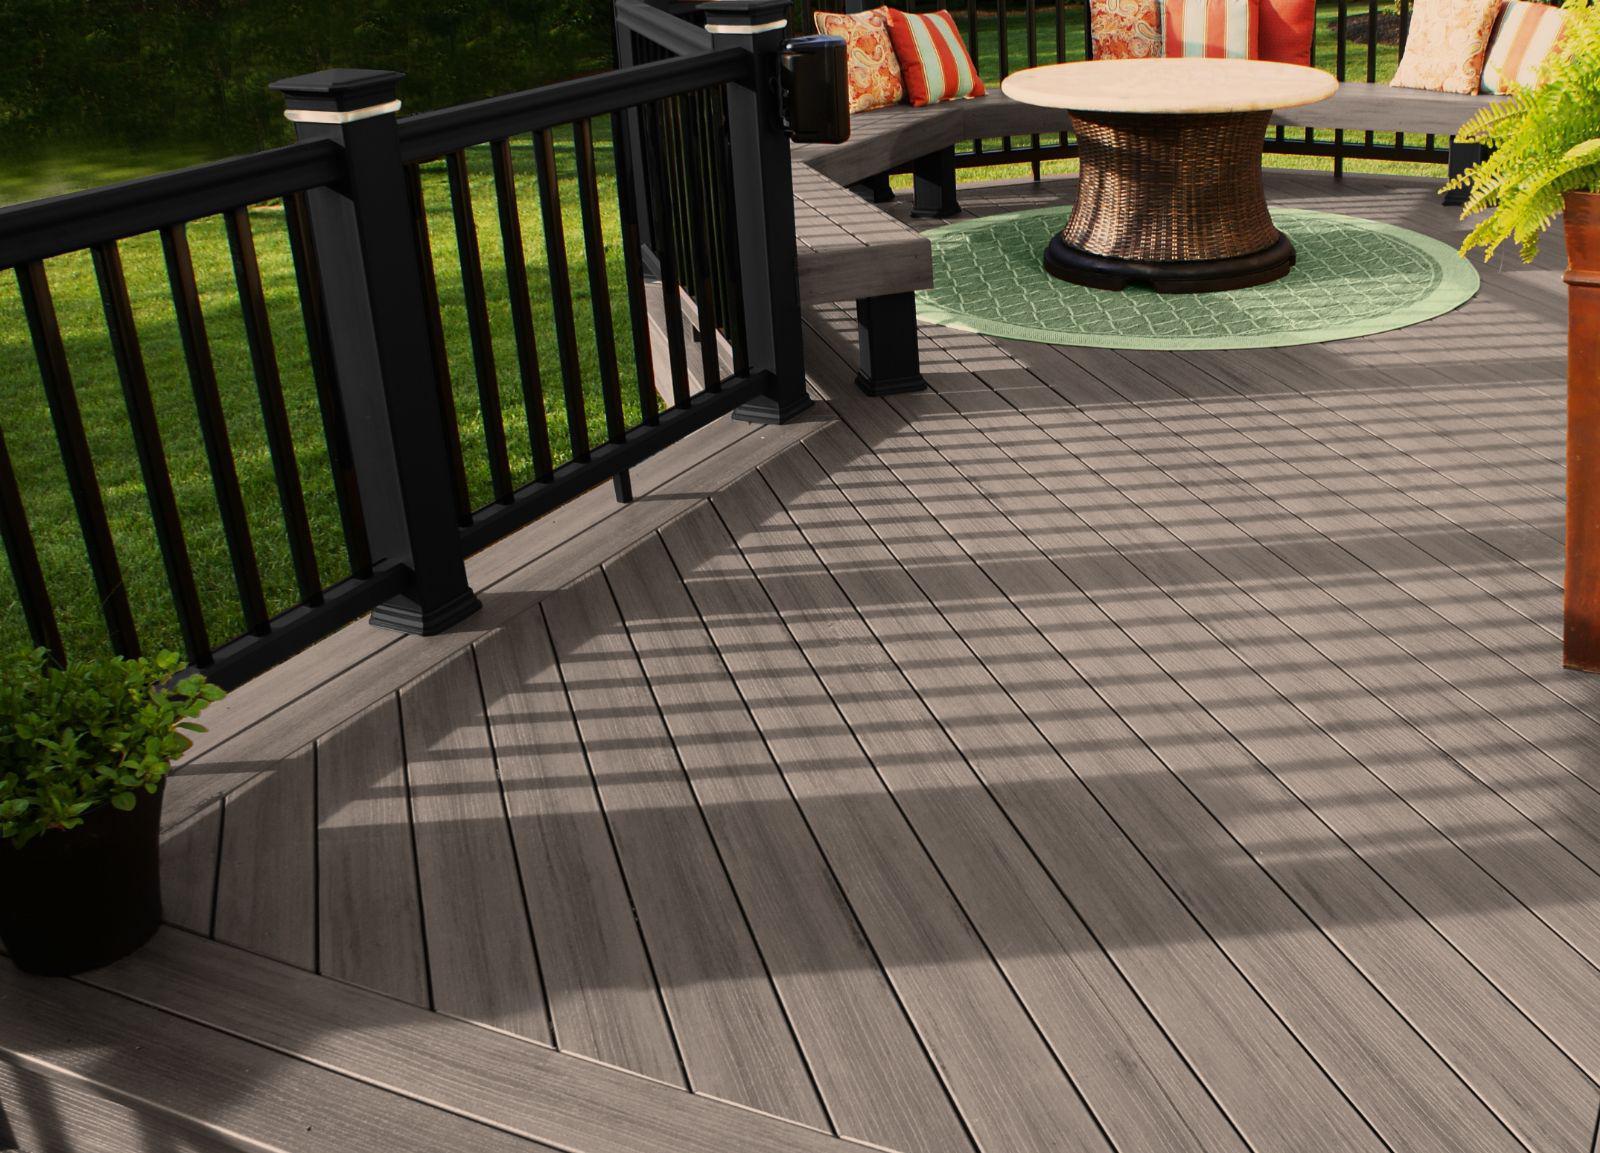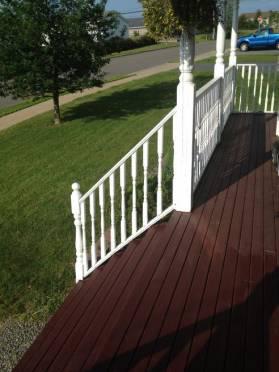The first image is the image on the left, the second image is the image on the right. Examine the images to the left and right. Is the description "One deck has dark grey flooring with no furniture on it, and the other deck has brown stained flooring, white rails, and furniture including a table with four chairs." accurate? Answer yes or no. No. The first image is the image on the left, the second image is the image on the right. Given the left and right images, does the statement "A table and 4 chairs sits on a wooden deck with a white banister." hold true? Answer yes or no. No. 